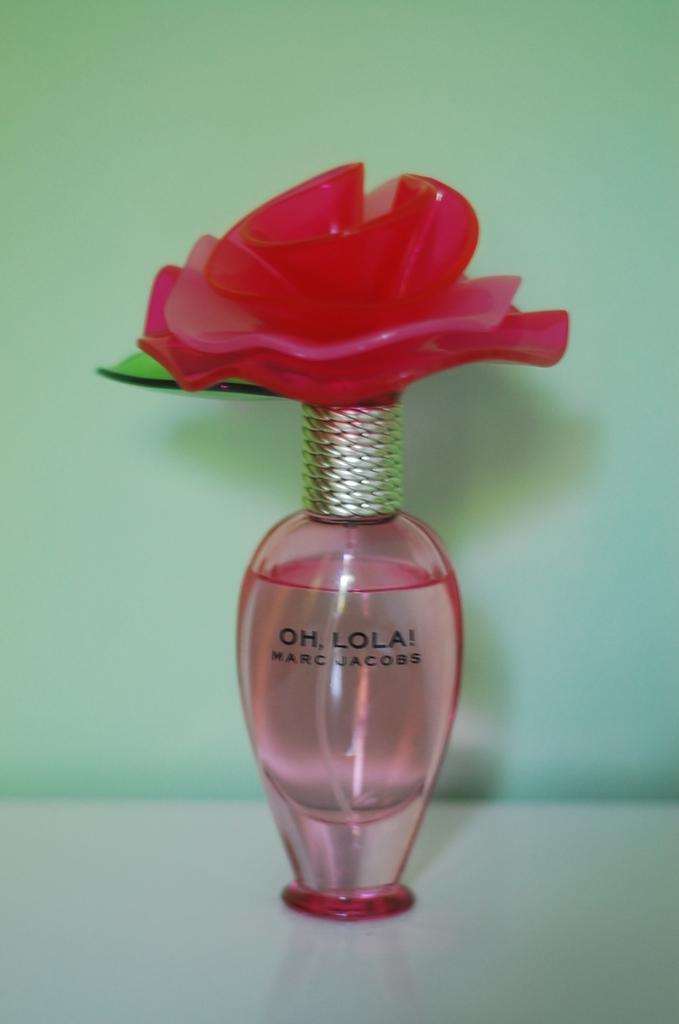What brand is the perfume?
Your response must be concise. Marc jacobs. What is the name of the perfume?
Your response must be concise. Oh, lola!. 